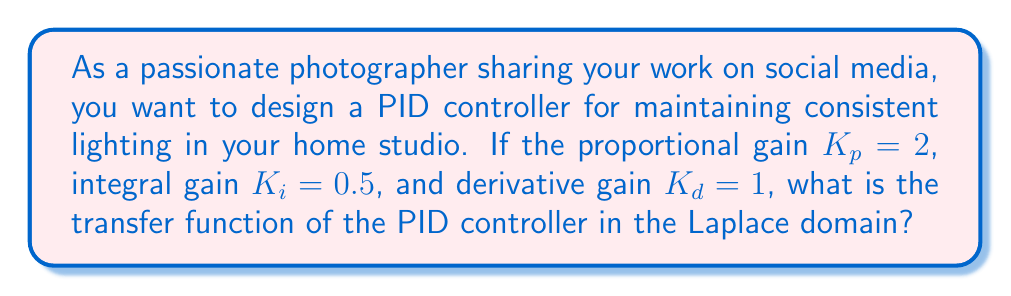Can you answer this question? To solve this problem, we need to understand the components of a PID controller and how they relate to the transfer function in the Laplace domain.

1. The general form of a PID controller in the time domain is:

   $$u(t) = K_p e(t) + K_i \int_0^t e(\tau) d\tau + K_d \frac{de(t)}{dt}$$

   where $u(t)$ is the control signal and $e(t)$ is the error signal.

2. To convert this to the Laplace domain, we need to apply the Laplace transform to each term:

   - Proportional term: $\mathcal{L}\{K_p e(t)\} = K_p E(s)$
   - Integral term: $\mathcal{L}\{K_i \int_0^t e(\tau) d\tau\} = K_i \frac{E(s)}{s}$
   - Derivative term: $\mathcal{L}\{K_d \frac{de(t)}{dt}\} = K_d s E(s)$

3. The transfer function of the PID controller is the ratio of the output to the input in the Laplace domain:

   $$G_{PID}(s) = \frac{U(s)}{E(s)} = K_p + \frac{K_i}{s} + K_d s$$

4. Substituting the given values:
   $K_p = 2$, $K_i = 0.5$, and $K_d = 1$

   $$G_{PID}(s) = 2 + \frac{0.5}{s} + s$$

5. To express this in a standard form, we can find a common denominator:

   $$G_{PID}(s) = \frac{2s^2 + 0.5 + s^3}{s}$$

This is the transfer function of the PID controller in the Laplace domain.
Answer: $$G_{PID}(s) = \frac{s^3 + 2s^2 + 0.5}{s}$$ 